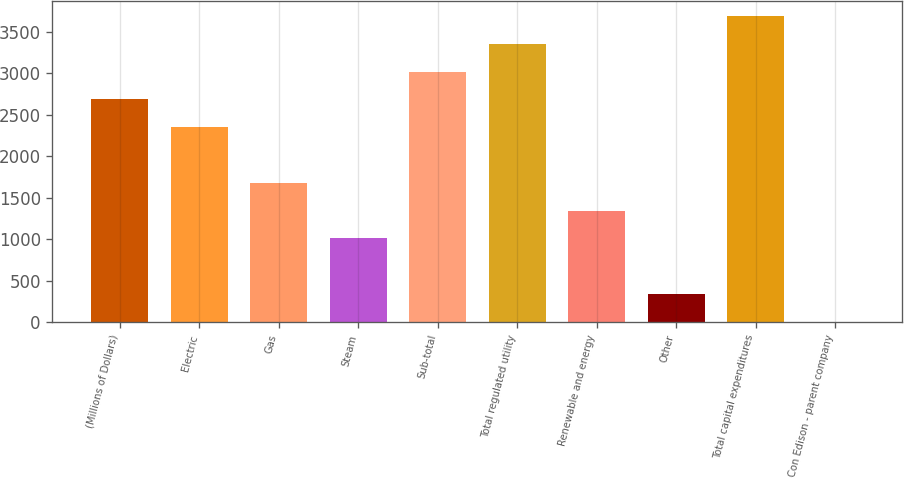Convert chart. <chart><loc_0><loc_0><loc_500><loc_500><bar_chart><fcel>(Millions of Dollars)<fcel>Electric<fcel>Gas<fcel>Steam<fcel>Sub-total<fcel>Total regulated utility<fcel>Renewable and energy<fcel>Other<fcel>Total capital expenditures<fcel>Con Edison - parent company<nl><fcel>2683.6<fcel>2348.4<fcel>1678<fcel>1007.6<fcel>3018.8<fcel>3354<fcel>1342.8<fcel>337.2<fcel>3689.2<fcel>2<nl></chart> 